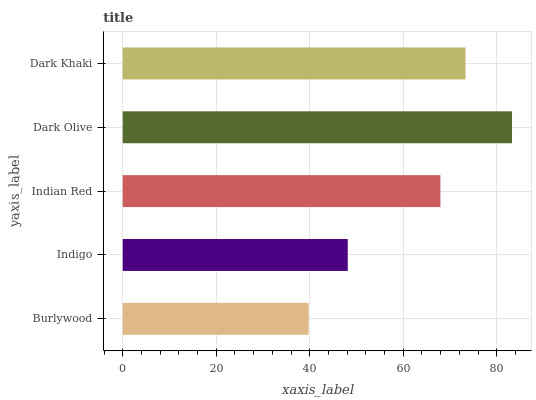Is Burlywood the minimum?
Answer yes or no. Yes. Is Dark Olive the maximum?
Answer yes or no. Yes. Is Indigo the minimum?
Answer yes or no. No. Is Indigo the maximum?
Answer yes or no. No. Is Indigo greater than Burlywood?
Answer yes or no. Yes. Is Burlywood less than Indigo?
Answer yes or no. Yes. Is Burlywood greater than Indigo?
Answer yes or no. No. Is Indigo less than Burlywood?
Answer yes or no. No. Is Indian Red the high median?
Answer yes or no. Yes. Is Indian Red the low median?
Answer yes or no. Yes. Is Burlywood the high median?
Answer yes or no. No. Is Dark Khaki the low median?
Answer yes or no. No. 